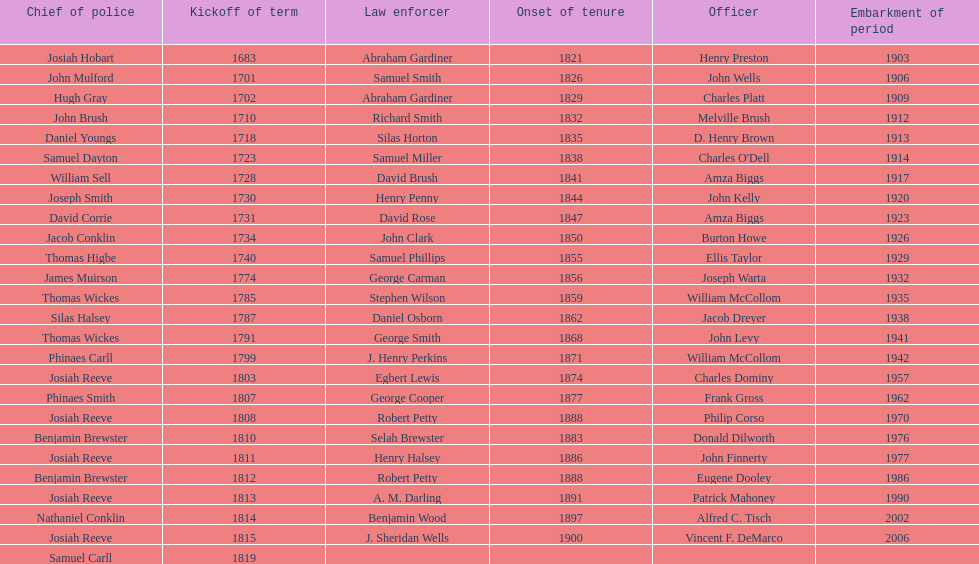Did robert petty serve before josiah reeve? No. Parse the full table. {'header': ['Chief of police', 'Kickoff of term', 'Law enforcer', 'Onset of tenure', 'Officer', 'Embarkment of period'], 'rows': [['Josiah Hobart', '1683', 'Abraham Gardiner', '1821', 'Henry Preston', '1903'], ['John Mulford', '1701', 'Samuel Smith', '1826', 'John Wells', '1906'], ['Hugh Gray', '1702', 'Abraham Gardiner', '1829', 'Charles Platt', '1909'], ['John Brush', '1710', 'Richard Smith', '1832', 'Melville Brush', '1912'], ['Daniel Youngs', '1718', 'Silas Horton', '1835', 'D. Henry Brown', '1913'], ['Samuel Dayton', '1723', 'Samuel Miller', '1838', "Charles O'Dell", '1914'], ['William Sell', '1728', 'David Brush', '1841', 'Amza Biggs', '1917'], ['Joseph Smith', '1730', 'Henry Penny', '1844', 'John Kelly', '1920'], ['David Corrie', '1731', 'David Rose', '1847', 'Amza Biggs', '1923'], ['Jacob Conklin', '1734', 'John Clark', '1850', 'Burton Howe', '1926'], ['Thomas Higbe', '1740', 'Samuel Phillips', '1855', 'Ellis Taylor', '1929'], ['James Muirson', '1774', 'George Carman', '1856', 'Joseph Warta', '1932'], ['Thomas Wickes', '1785', 'Stephen Wilson', '1859', 'William McCollom', '1935'], ['Silas Halsey', '1787', 'Daniel Osborn', '1862', 'Jacob Dreyer', '1938'], ['Thomas Wickes', '1791', 'George Smith', '1868', 'John Levy', '1941'], ['Phinaes Carll', '1799', 'J. Henry Perkins', '1871', 'William McCollom', '1942'], ['Josiah Reeve', '1803', 'Egbert Lewis', '1874', 'Charles Dominy', '1957'], ['Phinaes Smith', '1807', 'George Cooper', '1877', 'Frank Gross', '1962'], ['Josiah Reeve', '1808', 'Robert Petty', '1888', 'Philip Corso', '1970'], ['Benjamin Brewster', '1810', 'Selah Brewster', '1883', 'Donald Dilworth', '1976'], ['Josiah Reeve', '1811', 'Henry Halsey', '1886', 'John Finnerty', '1977'], ['Benjamin Brewster', '1812', 'Robert Petty', '1888', 'Eugene Dooley', '1986'], ['Josiah Reeve', '1813', 'A. M. Darling', '1891', 'Patrick Mahoney', '1990'], ['Nathaniel Conklin', '1814', 'Benjamin Wood', '1897', 'Alfred C. Tisch', '2002'], ['Josiah Reeve', '1815', 'J. Sheridan Wells', '1900', 'Vincent F. DeMarco', '2006'], ['Samuel Carll', '1819', '', '', '', '']]} 